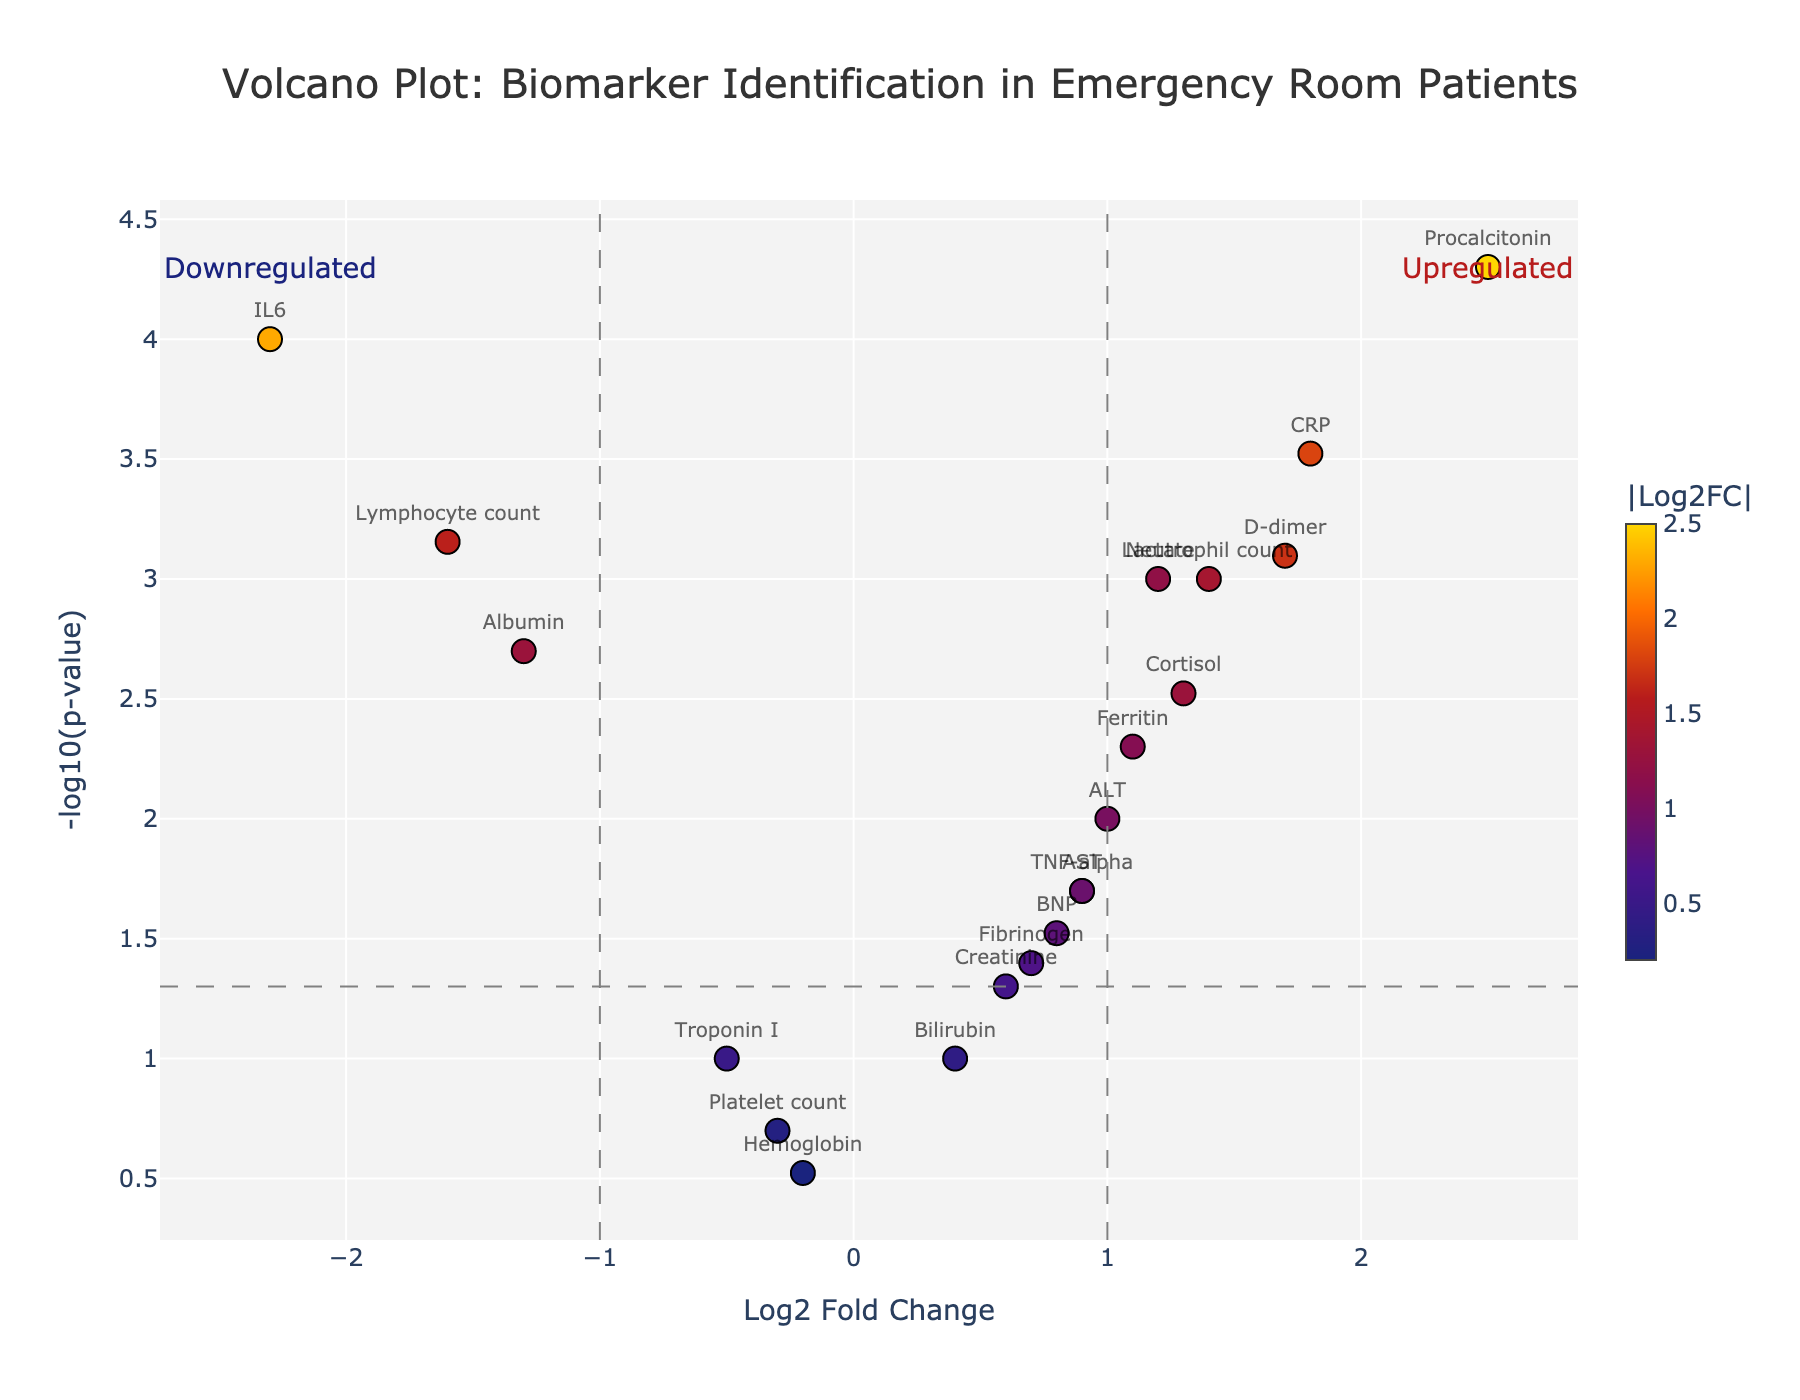What is the title of the figure? The title of a figure is usually displayed prominently at the top of the plot. In this case, it states, "Volcano Plot: Biomarker Identification in Emergency Room Patients."
Answer: Volcano Plot: Biomarker Identification in Emergency Room Patients How many genes have a Log2FoldChange higher than 1 and a p-value less than 0.05? In the volcano plot, genes that fulfill both conditions (Log2FoldChange > 1 and p-value < 0.05) are represented as points to the right of the vertical significance line (fc_threshold = 1) and above the horizontal significance line (p_threshold = 0.05). Counting these points gives us the answer.
Answer: 7 Which biomarker has the smallest p-value? To determine the smallest p-value, we look for the highest point along the y-axis (-log10(p-value)) in the plot. The gene represented at the highest point will have the lowest p-value. In this case, it is "Procalcitonin."
Answer: Procalcitonin Which biomarker is the most downregulated? The most downregulated gene will have the lowest Log2FoldChange value. In the plot, this corresponds to the farthest left point on the x-axis. Here, the most downregulated biomarker is "IL6."
Answer: IL6 Which biomarkers have a Log2FoldChange between 1.0 and 2.0 and a p-value less than 0.01? To identify these biomarkers, we look for points within the range of 1.0 to 2.0 on the x-axis and above the horizontal line at -log10(0.01) on the y-axis. This includes markers "CRP," "Lactate," and "D-dimer."
Answer: CRP, Lactate, D-dimer Are there any biomarkers that are not significantly different between the two patient groups? Biomarkers that are not significantly different will have a p-value greater than 0.05, and thus lie below the horizontal significance line on the y-axis (-log10(0.05) = 1.3). These include "Troponin I," "Platelet count," and "Hemoglobin.”
Answer: Troponin I, Platelet count, Hemoglobin Which upregulated biomarker has the highest -log10(p-value)? Among the upregulated biomarkers (Log2FoldChange > 0), the one with the highest -log10(p-value) will be the highest point on the y-axis. This is "Procalcitonin."
Answer: Procalcitonin How many biomarkers have Log2FoldChange less than -1 and p-value less than 0.01? To find these biomarkers, we look at points to the left of the vertical significance line (fc_threshold) and above the horizontal line at -log10(0.01). This includes the biomarkers "IL6” and "Lymphocyte count."
Answer: 2 